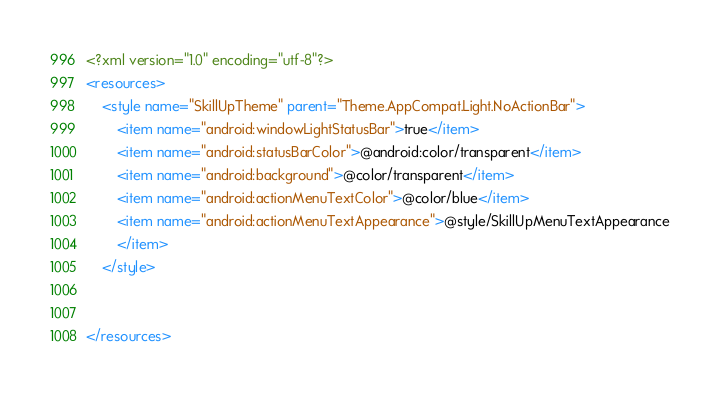Convert code to text. <code><loc_0><loc_0><loc_500><loc_500><_XML_><?xml version="1.0" encoding="utf-8"?>
<resources>
    <style name="SkillUpTheme" parent="Theme.AppCompat.Light.NoActionBar">
        <item name="android:windowLightStatusBar">true</item>
        <item name="android:statusBarColor">@android:color/transparent</item>
        <item name="android:background">@color/transparent</item>
        <item name="android:actionMenuTextColor">@color/blue</item>
        <item name="android:actionMenuTextAppearance">@style/SkillUpMenuTextAppearance
        </item>
    </style>


</resources></code> 